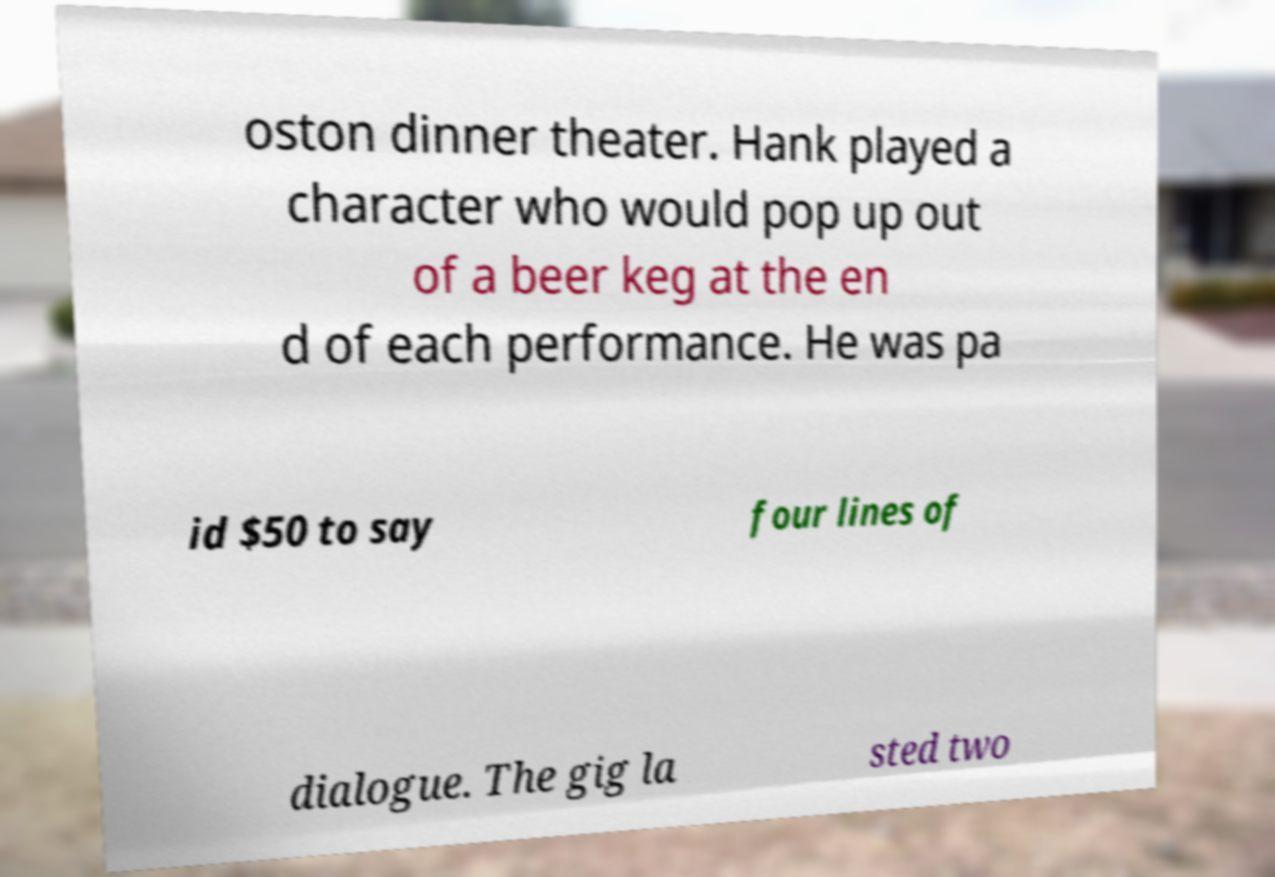I need the written content from this picture converted into text. Can you do that? oston dinner theater. Hank played a character who would pop up out of a beer keg at the en d of each performance. He was pa id $50 to say four lines of dialogue. The gig la sted two 